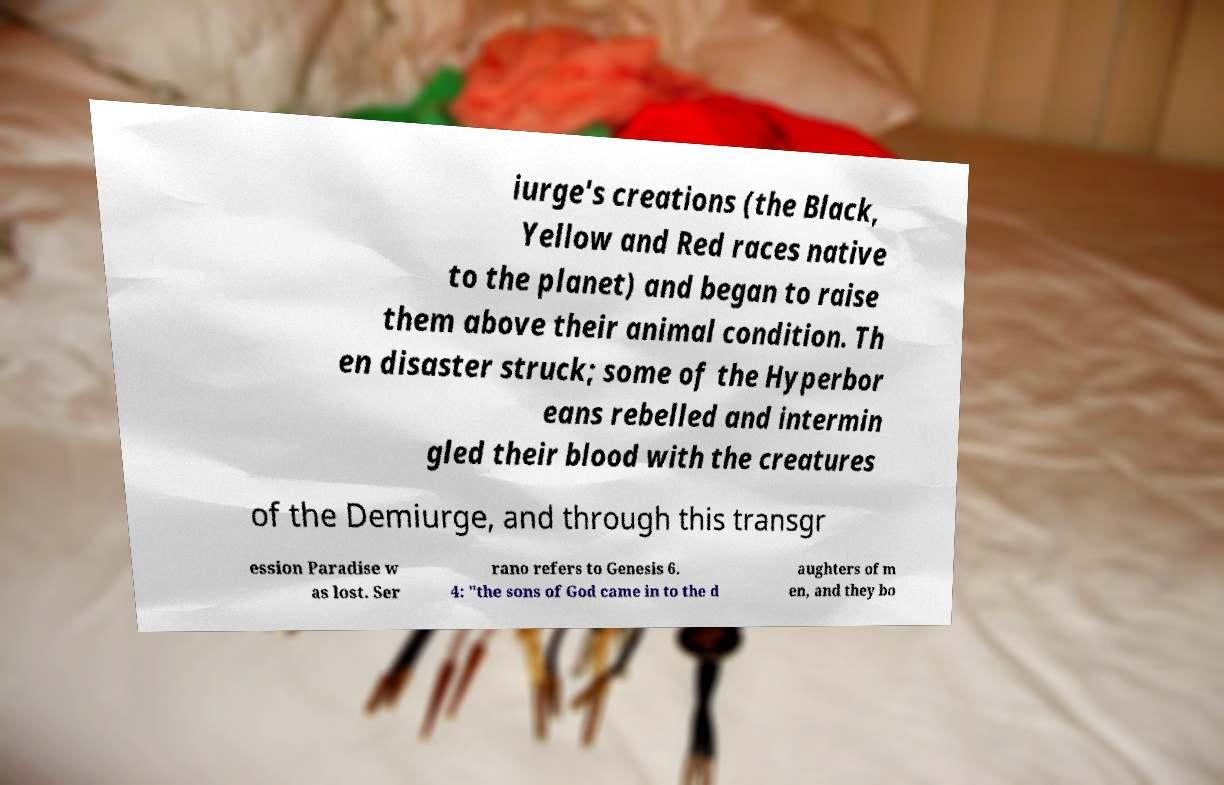Can you read and provide the text displayed in the image?This photo seems to have some interesting text. Can you extract and type it out for me? iurge's creations (the Black, Yellow and Red races native to the planet) and began to raise them above their animal condition. Th en disaster struck; some of the Hyperbor eans rebelled and intermin gled their blood with the creatures of the Demiurge, and through this transgr ession Paradise w as lost. Ser rano refers to Genesis 6. 4: "the sons of God came in to the d aughters of m en, and they bo 